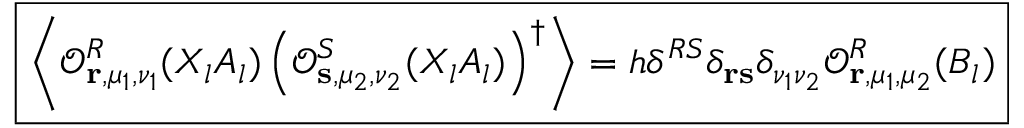Convert formula to latex. <formula><loc_0><loc_0><loc_500><loc_500>\boxed { \left \langle \mathcal { O } _ { r , \mu _ { 1 } , \nu _ { 1 } } ^ { R } ( X _ { l } A _ { l } ) \left ( \mathcal { O } _ { s , \mu _ { 2 } , \nu _ { 2 } } ^ { S } ( X _ { l } A _ { l } ) \right ) ^ { \dagger } \right \rangle = h \delta ^ { R S } \delta _ { r s } \delta _ { \nu _ { 1 } \nu _ { 2 } } \mathcal { O } _ { r , \mu _ { 1 } , \mu _ { 2 } } ^ { R } ( B _ { l } ) }</formula> 